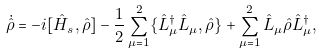Convert formula to latex. <formula><loc_0><loc_0><loc_500><loc_500>\dot { \hat { \rho } } = - i [ \hat { H } _ { s } , \hat { \rho } ] - \frac { 1 } { 2 } \sum _ { \mu = 1 } ^ { 2 } \{ \hat { L } _ { \mu } ^ { \dag } \hat { L } _ { \mu } , \hat { \rho } \} + \sum _ { \mu = 1 } ^ { 2 } \hat { L } _ { \mu } \hat { \rho } \hat { L } _ { \mu } ^ { \dag } ,</formula> 